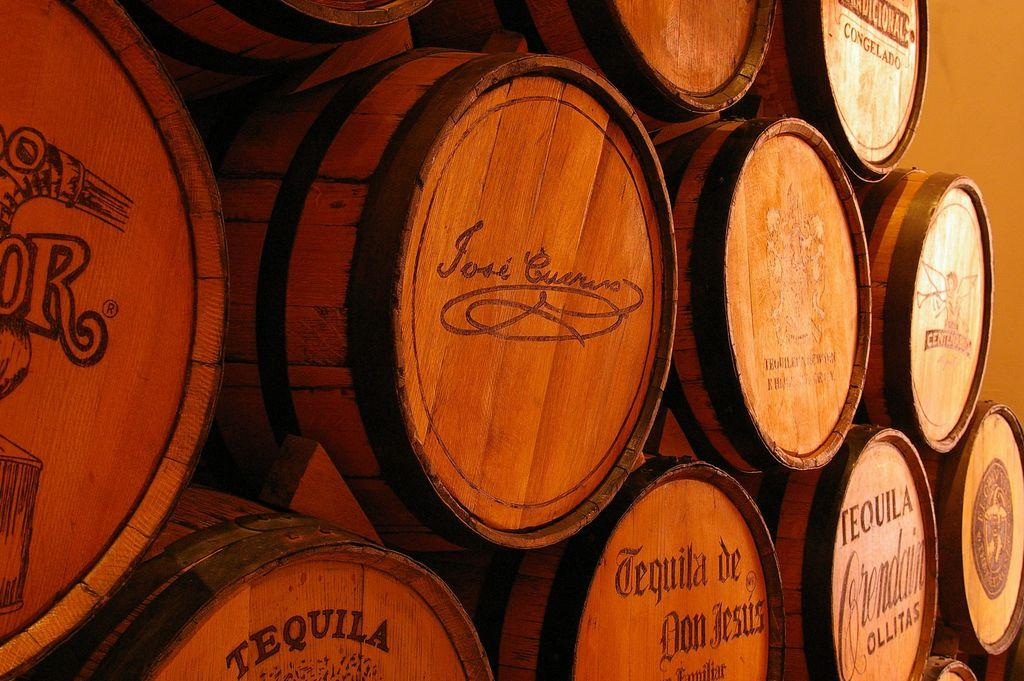What type of musical instrument is present in the image? There are wooden drums in the image. Where are the wooden drums located? The wooden drums are kept on the floor. What type of sound does the thunder make in the image? There is no thunder present in the image; it only features wooden drums. What type of furniture is present in the image? The provided facts do not mention any furniture in the image, such as a chair or tray. 